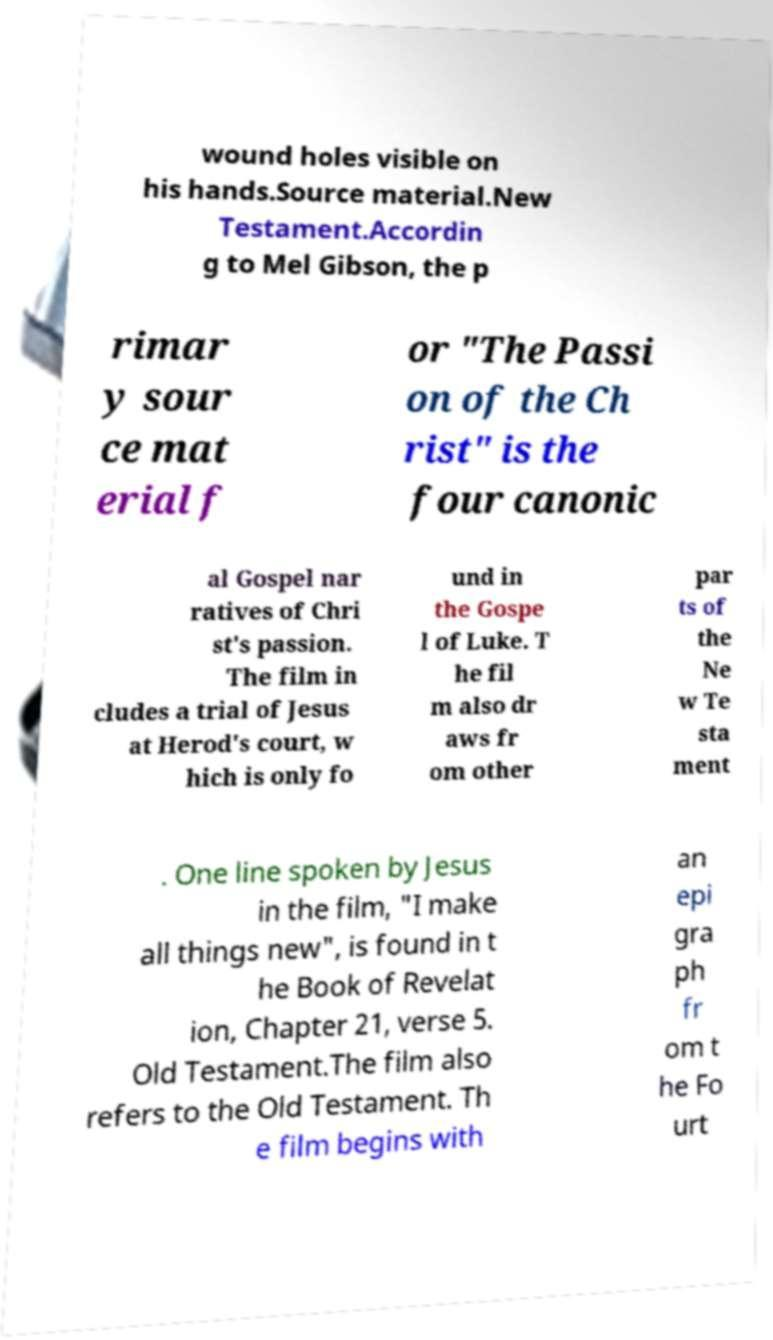Please identify and transcribe the text found in this image. wound holes visible on his hands.Source material.New Testament.Accordin g to Mel Gibson, the p rimar y sour ce mat erial f or "The Passi on of the Ch rist" is the four canonic al Gospel nar ratives of Chri st's passion. The film in cludes a trial of Jesus at Herod's court, w hich is only fo und in the Gospe l of Luke. T he fil m also dr aws fr om other par ts of the Ne w Te sta ment . One line spoken by Jesus in the film, "I make all things new", is found in t he Book of Revelat ion, Chapter 21, verse 5. Old Testament.The film also refers to the Old Testament. Th e film begins with an epi gra ph fr om t he Fo urt 